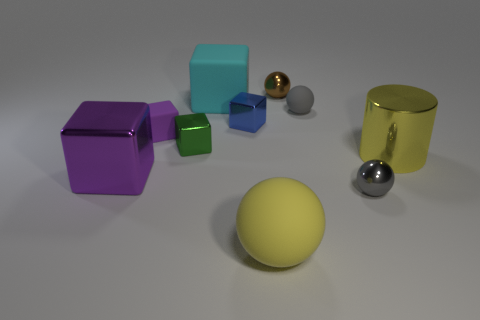What material is the purple object in front of the tiny purple block?
Keep it short and to the point. Metal. How big is the blue cube?
Offer a terse response. Small. How many brown objects are shiny objects or small metallic cubes?
Your answer should be compact. 1. How big is the shiny cube right of the big cyan object behind the large yellow rubber object?
Offer a terse response. Small. Does the large matte cube have the same color as the big thing that is on the right side of the gray metal sphere?
Ensure brevity in your answer.  No. What number of other objects are the same material as the cyan thing?
Ensure brevity in your answer.  3. There is a tiny green object that is made of the same material as the brown ball; what shape is it?
Provide a succinct answer. Cube. Is there anything else that has the same color as the large cylinder?
Provide a short and direct response. Yes. The object that is the same color as the large sphere is what size?
Make the answer very short. Large. Is the number of small gray metal objects on the right side of the large yellow cylinder greater than the number of tiny rubber objects?
Your answer should be compact. No. 